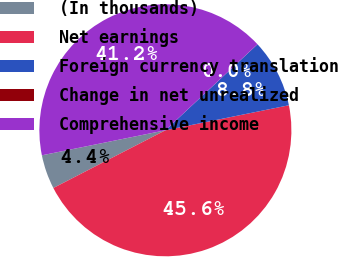<chart> <loc_0><loc_0><loc_500><loc_500><pie_chart><fcel>(In thousands)<fcel>Net earnings<fcel>Foreign currency translation<fcel>Change in net unrealized<fcel>Comprehensive income<nl><fcel>4.39%<fcel>45.61%<fcel>8.77%<fcel>0.01%<fcel>41.22%<nl></chart> 